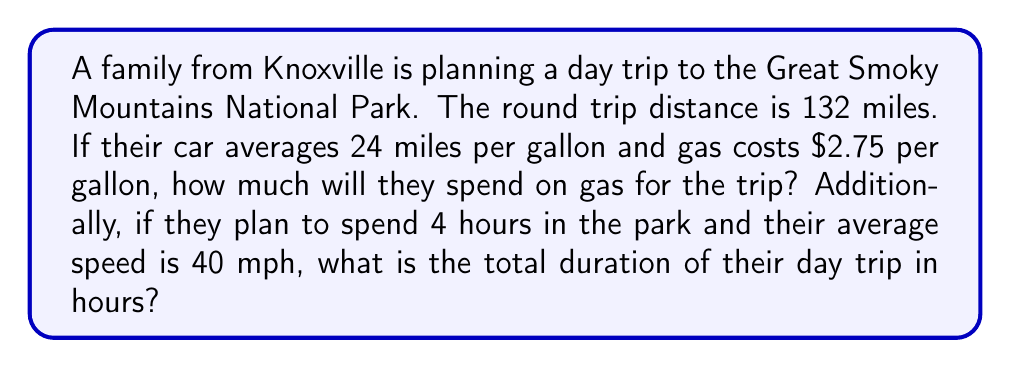Teach me how to tackle this problem. Let's break this problem into two parts:

1. Calculating the gas cost:
   a) First, we need to find out how many gallons of gas the trip will consume:
      $$ \text{Gallons of gas} = \frac{\text{Total distance}}{\text{Miles per gallon}} = \frac{132}{24} = 5.5 \text{ gallons} $$
   b) Now, we can calculate the cost of gas:
      $$ \text{Gas cost} = \text{Gallons of gas} \times \text{Price per gallon} = 5.5 \times $2.75 = $15.13 $$

2. Calculating the total trip duration:
   a) First, let's calculate the travel time:
      $$ \text{Travel time} = \frac{\text{Total distance}}{\text{Average speed}} = \frac{132}{40} = 3.3 \text{ hours} $$
   b) Now, we can add the time spent in the park to get the total duration:
      $$ \text{Total duration} = \text{Travel time} + \text{Time in park} = 3.3 + 4 = 7.3 \text{ hours} $$

Therefore, the family will spend $15.13 on gas and their day trip will last 7.3 hours in total.
Answer: $15.13 on gas; 7.3 hours total 